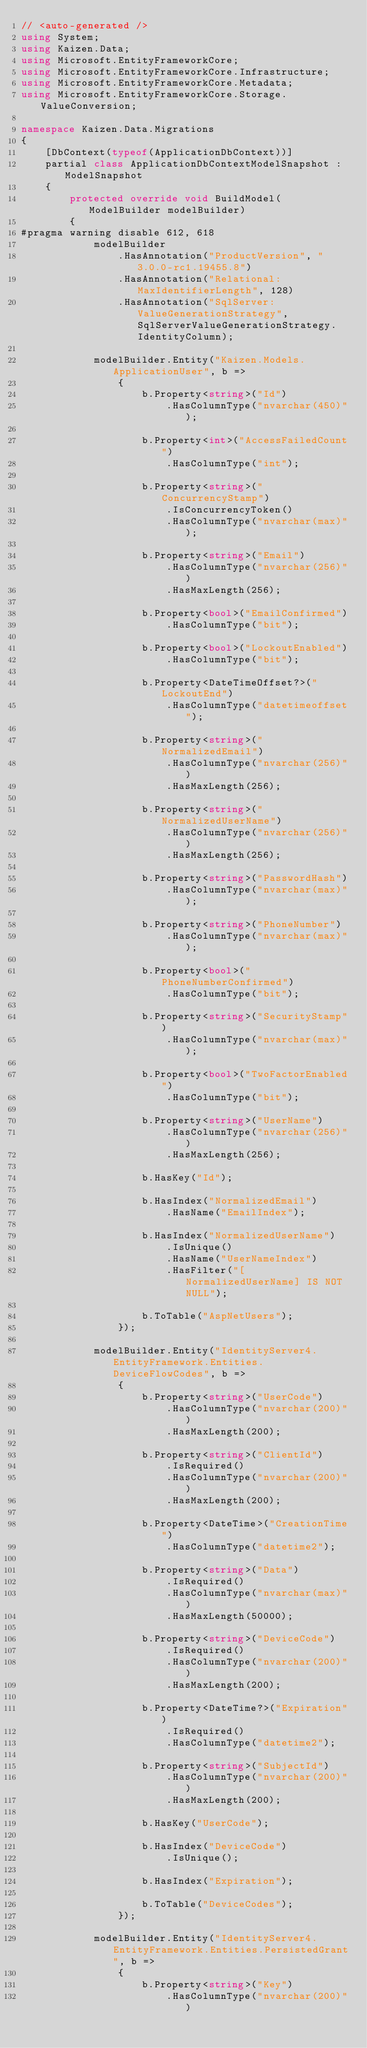<code> <loc_0><loc_0><loc_500><loc_500><_C#_>// <auto-generated />
using System;
using Kaizen.Data;
using Microsoft.EntityFrameworkCore;
using Microsoft.EntityFrameworkCore.Infrastructure;
using Microsoft.EntityFrameworkCore.Metadata;
using Microsoft.EntityFrameworkCore.Storage.ValueConversion;

namespace Kaizen.Data.Migrations
{
    [DbContext(typeof(ApplicationDbContext))]
    partial class ApplicationDbContextModelSnapshot : ModelSnapshot
    {
        protected override void BuildModel(ModelBuilder modelBuilder)
        {
#pragma warning disable 612, 618
            modelBuilder
                .HasAnnotation("ProductVersion", "3.0.0-rc1.19455.8")
                .HasAnnotation("Relational:MaxIdentifierLength", 128)
                .HasAnnotation("SqlServer:ValueGenerationStrategy", SqlServerValueGenerationStrategy.IdentityColumn);

            modelBuilder.Entity("Kaizen.Models.ApplicationUser", b =>
                {
                    b.Property<string>("Id")
                        .HasColumnType("nvarchar(450)");

                    b.Property<int>("AccessFailedCount")
                        .HasColumnType("int");

                    b.Property<string>("ConcurrencyStamp")
                        .IsConcurrencyToken()
                        .HasColumnType("nvarchar(max)");

                    b.Property<string>("Email")
                        .HasColumnType("nvarchar(256)")
                        .HasMaxLength(256);

                    b.Property<bool>("EmailConfirmed")
                        .HasColumnType("bit");

                    b.Property<bool>("LockoutEnabled")
                        .HasColumnType("bit");

                    b.Property<DateTimeOffset?>("LockoutEnd")
                        .HasColumnType("datetimeoffset");

                    b.Property<string>("NormalizedEmail")
                        .HasColumnType("nvarchar(256)")
                        .HasMaxLength(256);

                    b.Property<string>("NormalizedUserName")
                        .HasColumnType("nvarchar(256)")
                        .HasMaxLength(256);

                    b.Property<string>("PasswordHash")
                        .HasColumnType("nvarchar(max)");

                    b.Property<string>("PhoneNumber")
                        .HasColumnType("nvarchar(max)");

                    b.Property<bool>("PhoneNumberConfirmed")
                        .HasColumnType("bit");

                    b.Property<string>("SecurityStamp")
                        .HasColumnType("nvarchar(max)");

                    b.Property<bool>("TwoFactorEnabled")
                        .HasColumnType("bit");

                    b.Property<string>("UserName")
                        .HasColumnType("nvarchar(256)")
                        .HasMaxLength(256);

                    b.HasKey("Id");

                    b.HasIndex("NormalizedEmail")
                        .HasName("EmailIndex");

                    b.HasIndex("NormalizedUserName")
                        .IsUnique()
                        .HasName("UserNameIndex")
                        .HasFilter("[NormalizedUserName] IS NOT NULL");

                    b.ToTable("AspNetUsers");
                });

            modelBuilder.Entity("IdentityServer4.EntityFramework.Entities.DeviceFlowCodes", b =>
                {
                    b.Property<string>("UserCode")
                        .HasColumnType("nvarchar(200)")
                        .HasMaxLength(200);

                    b.Property<string>("ClientId")
                        .IsRequired()
                        .HasColumnType("nvarchar(200)")
                        .HasMaxLength(200);

                    b.Property<DateTime>("CreationTime")
                        .HasColumnType("datetime2");

                    b.Property<string>("Data")
                        .IsRequired()
                        .HasColumnType("nvarchar(max)")
                        .HasMaxLength(50000);

                    b.Property<string>("DeviceCode")
                        .IsRequired()
                        .HasColumnType("nvarchar(200)")
                        .HasMaxLength(200);

                    b.Property<DateTime?>("Expiration")
                        .IsRequired()
                        .HasColumnType("datetime2");

                    b.Property<string>("SubjectId")
                        .HasColumnType("nvarchar(200)")
                        .HasMaxLength(200);

                    b.HasKey("UserCode");

                    b.HasIndex("DeviceCode")
                        .IsUnique();

                    b.HasIndex("Expiration");

                    b.ToTable("DeviceCodes");
                });

            modelBuilder.Entity("IdentityServer4.EntityFramework.Entities.PersistedGrant", b =>
                {
                    b.Property<string>("Key")
                        .HasColumnType("nvarchar(200)")</code> 